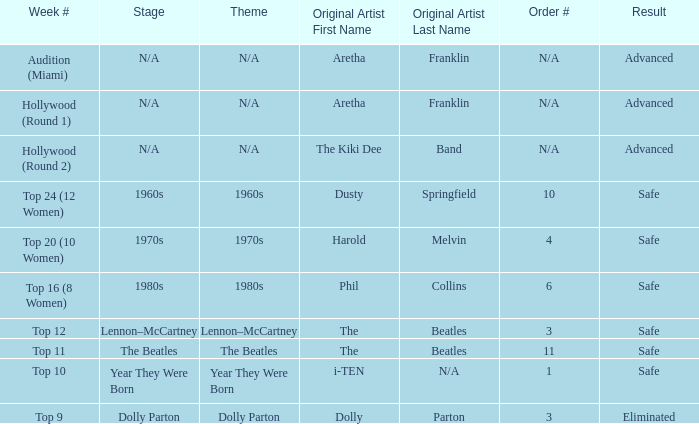What is the order number that has Aretha Franklin as the original artist? N/A, N/A. 